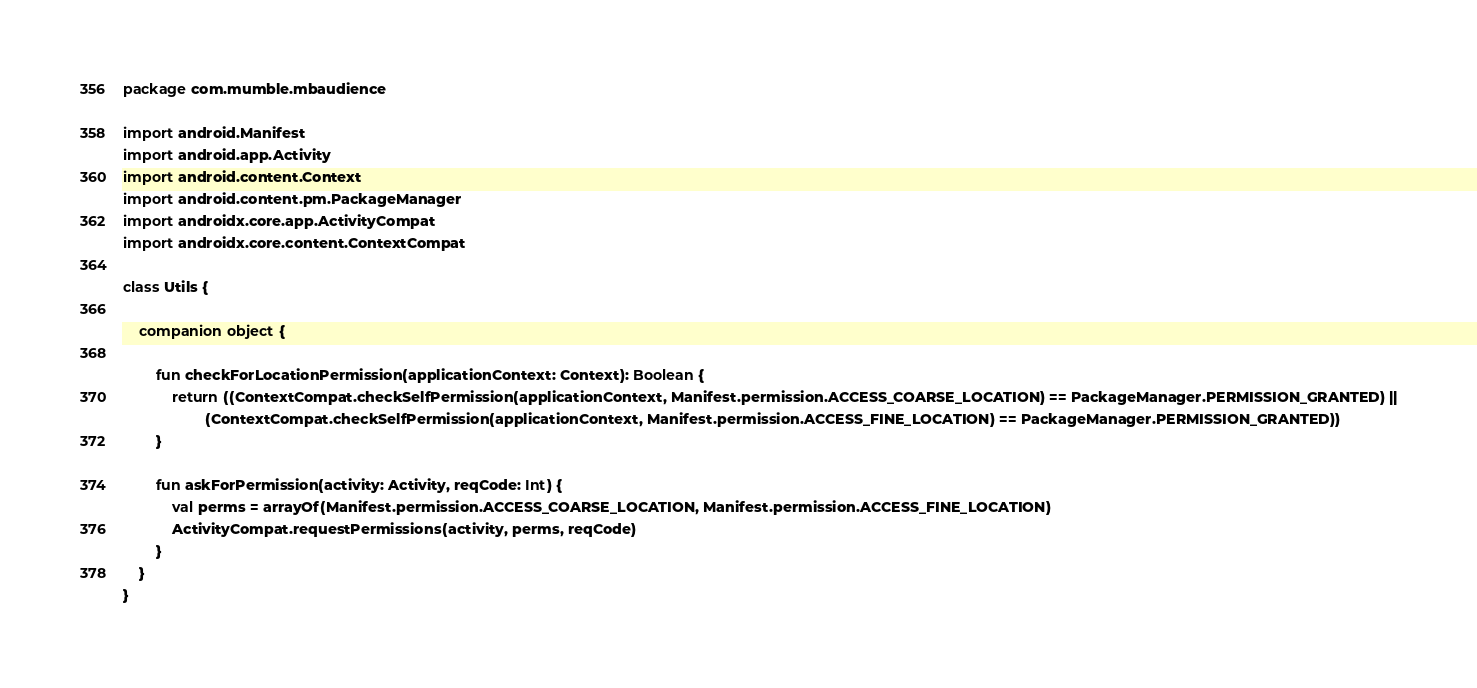Convert code to text. <code><loc_0><loc_0><loc_500><loc_500><_Kotlin_>package com.mumble.mbaudience

import android.Manifest
import android.app.Activity
import android.content.Context
import android.content.pm.PackageManager
import androidx.core.app.ActivityCompat
import androidx.core.content.ContextCompat

class Utils {

    companion object {

        fun checkForLocationPermission(applicationContext: Context): Boolean {
            return ((ContextCompat.checkSelfPermission(applicationContext, Manifest.permission.ACCESS_COARSE_LOCATION) == PackageManager.PERMISSION_GRANTED) ||
                    (ContextCompat.checkSelfPermission(applicationContext, Manifest.permission.ACCESS_FINE_LOCATION) == PackageManager.PERMISSION_GRANTED))
        }

        fun askForPermission(activity: Activity, reqCode: Int) {
            val perms = arrayOf(Manifest.permission.ACCESS_COARSE_LOCATION, Manifest.permission.ACCESS_FINE_LOCATION)
            ActivityCompat.requestPermissions(activity, perms, reqCode)
        }
    }
}</code> 